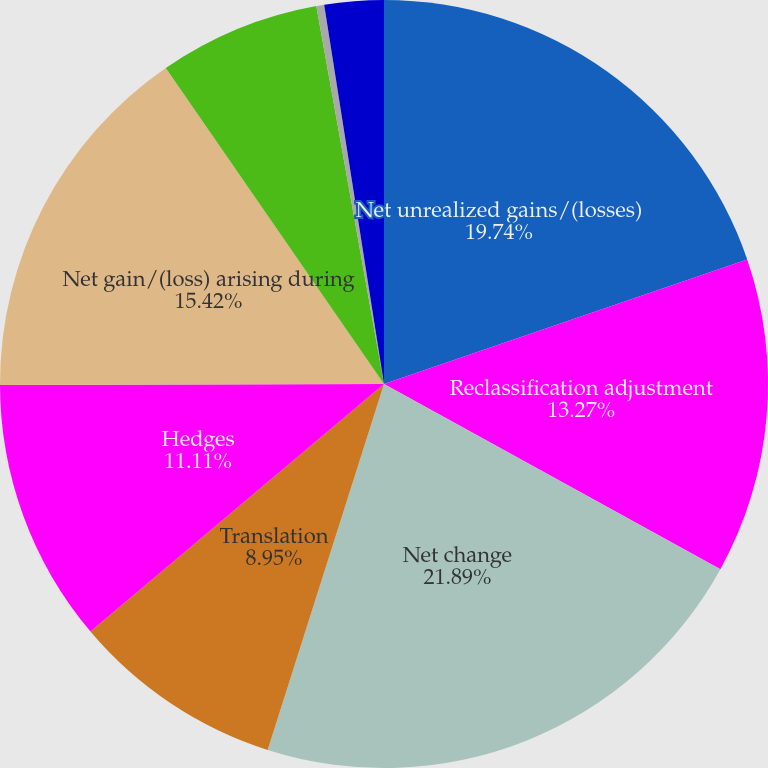Convert chart. <chart><loc_0><loc_0><loc_500><loc_500><pie_chart><fcel>Net unrealized gains/(losses)<fcel>Reclassification adjustment<fcel>Net change<fcel>Translation<fcel>Hedges<fcel>Net gain/(loss) arising during<fcel>Amortization of net loss<fcel>Amortization of prior service<fcel>Foreign exchange and other<nl><fcel>19.74%<fcel>13.27%<fcel>21.89%<fcel>8.95%<fcel>11.11%<fcel>15.42%<fcel>6.8%<fcel>0.33%<fcel>2.49%<nl></chart> 